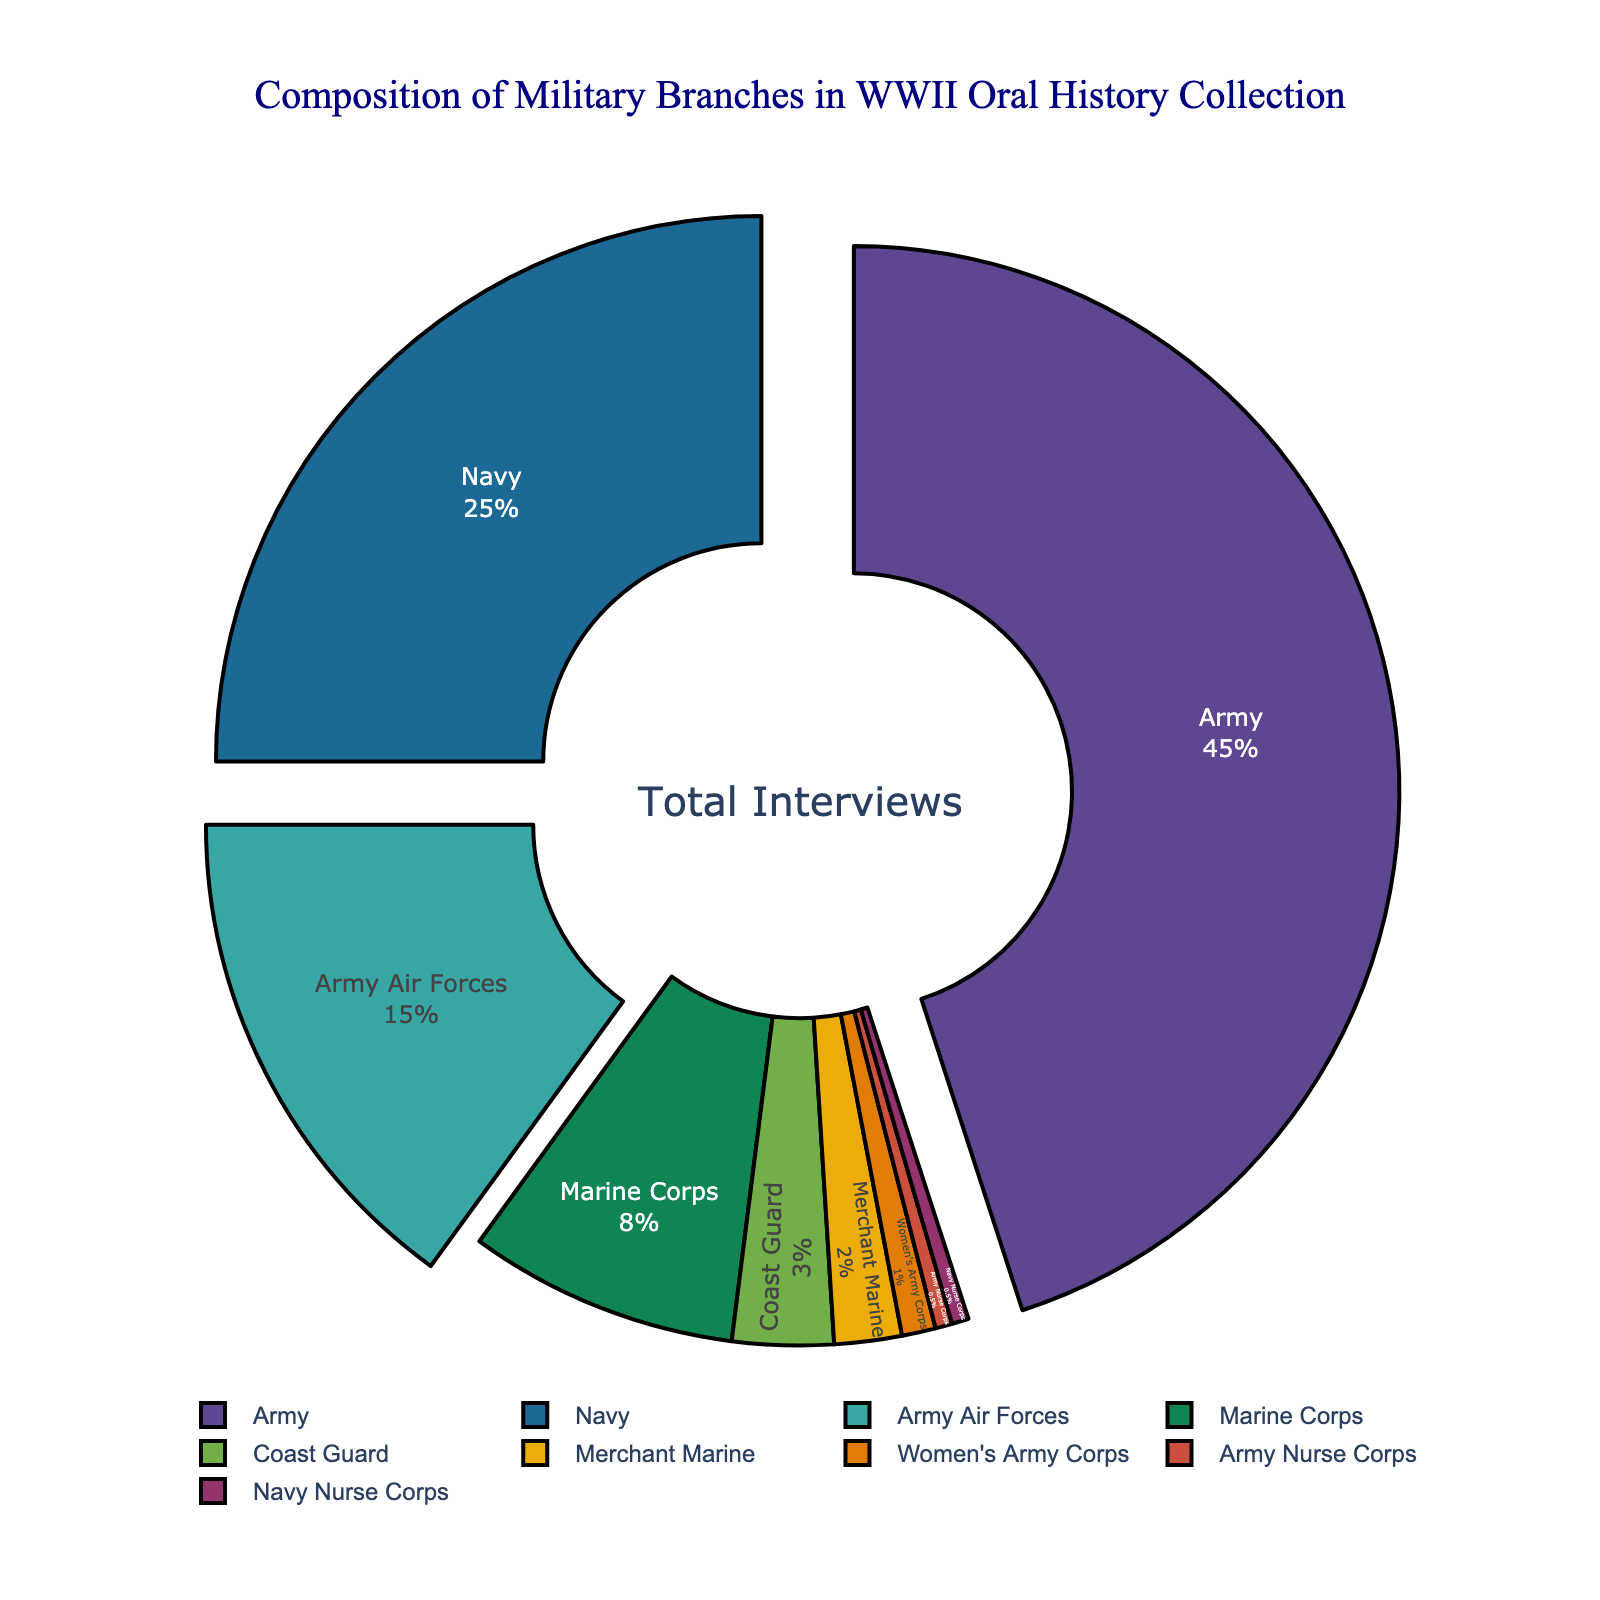What's the combined percentage of the Army and Navy branches? To find the combined percentage, we add the percentages of the Army (45%) and Navy (25%). 45% + 25% = 70%.
Answer: 70% Which branch has a higher percentage, the Marine Corps or the Merchant Marine? Comparing the percentages: Marine Corps (8%) versus Merchant Marine (2%). 8% is greater than 2%, so the Marine Corps has a higher percentage.
Answer: Marine Corps What is the percentage difference between the Army Air Forces and the Coast Guard? Subtract the smaller percentage from the larger percentage: Army Air Forces (15%) - Coast Guard (3%) = 12%.
Answer: 12% What are the three branches with the largest slices pulled out from the pie chart? The three largest percentages in the chart are Army (45%), Navy (25%), and Army Air Forces (15%). These slices are pulled out.
Answer: Army, Navy, Army Air Forces How does the percentage of the Women's Army Corps compare to the Army Nurse Corps? Both the Women's Army Corps and the Army Nurse Corps have small percentages, but the Women's Army Corps (1%) is larger than the Army Nurse Corps (0.5%).
Answer: Women's Army Corps If you add the percentages of the Army, Navy, and Army Air Forces, what is the total? Adding the percentages of Army (45%), Navy (25%), and Army Air Forces (15%): 45% + 25% + 15% = 85%.
Answer: 85% Which branch has the smallest representation in the collection, and what is its percentage? The branch with the smallest representation is determined by finding the smallest percentage, which is shared by the Army Nurse Corps and Navy Nurse Corps, both at 0.5%.
Answer: Army Nurse Corps and Navy Nurse Corps Looking at the colors, which branch appears in the darkest color? The Army represents the largest percentage (45%) and is often colored distinctively. However, exact colors may vary; generally, the first color in qualitative palettes is darker.
Answer: Army (typically) How much larger is the Navy's representation compared to the Marine Corps? Subtract the Marine Corps percentage from the Navy's percentage: Navy (25%) - Marine Corps (8%) = 17%.
Answer: 17% Which branches make up less than 5% of the collection? Identify branches with percentages less than 5%. These are the Coast Guard (3%), Merchant Marine (2%), Women's Army Corps (1%), Army Nurse Corps (0.5%), and Navy Nurse Corps (0.5%).
Answer: Coast Guard, Merchant Marine, Women's Army Corps, Army Nurse Corps, Navy Nurse Corps 